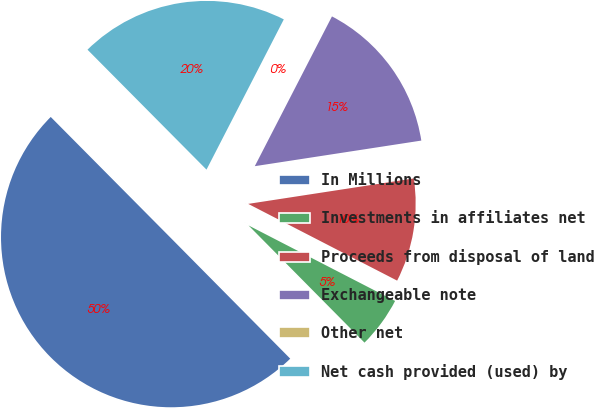<chart> <loc_0><loc_0><loc_500><loc_500><pie_chart><fcel>In Millions<fcel>Investments in affiliates net<fcel>Proceeds from disposal of land<fcel>Exchangeable note<fcel>Other net<fcel>Net cash provided (used) by<nl><fcel>49.98%<fcel>5.01%<fcel>10.0%<fcel>15.0%<fcel>0.01%<fcel>20.0%<nl></chart> 